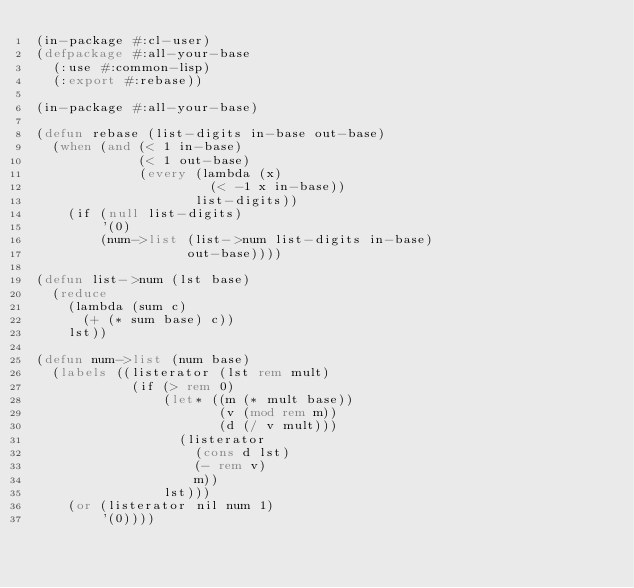<code> <loc_0><loc_0><loc_500><loc_500><_Lisp_>(in-package #:cl-user)
(defpackage #:all-your-base
  (:use #:common-lisp)
  (:export #:rebase))

(in-package #:all-your-base)

(defun rebase (list-digits in-base out-base)
  (when (and (< 1 in-base)
             (< 1 out-base)
             (every (lambda (x)
                      (< -1 x in-base))
                    list-digits))
    (if (null list-digits)
        '(0)
        (num->list (list->num list-digits in-base)
                   out-base))))

(defun list->num (lst base)
  (reduce
    (lambda (sum c)
      (+ (* sum base) c))
    lst))

(defun num->list (num base)
  (labels ((listerator (lst rem mult)
            (if (> rem 0)
                (let* ((m (* mult base))
                       (v (mod rem m))
                       (d (/ v mult)))
                  (listerator
                    (cons d lst)
                    (- rem v)
                    m))
                lst)))
    (or (listerator nil num 1)
        '(0))))
</code> 